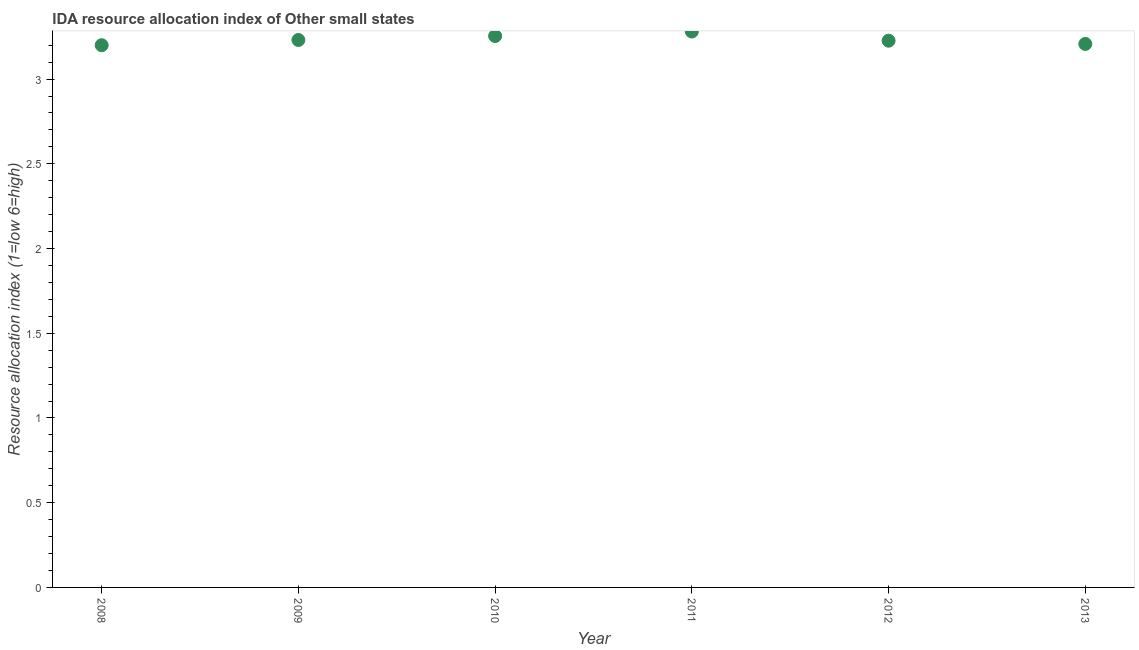Across all years, what is the maximum ida resource allocation index?
Give a very brief answer. 3.28. Across all years, what is the minimum ida resource allocation index?
Your answer should be very brief. 3.2. What is the sum of the ida resource allocation index?
Your response must be concise. 19.4. What is the difference between the ida resource allocation index in 2009 and 2011?
Your answer should be very brief. -0.05. What is the average ida resource allocation index per year?
Ensure brevity in your answer.  3.23. What is the median ida resource allocation index?
Make the answer very short. 3.23. In how many years, is the ida resource allocation index greater than 0.30000000000000004 ?
Your response must be concise. 6. Do a majority of the years between 2009 and 2013 (inclusive) have ida resource allocation index greater than 1.9 ?
Make the answer very short. Yes. What is the ratio of the ida resource allocation index in 2008 to that in 2013?
Offer a very short reply. 1. Is the difference between the ida resource allocation index in 2009 and 2010 greater than the difference between any two years?
Provide a short and direct response. No. What is the difference between the highest and the second highest ida resource allocation index?
Make the answer very short. 0.03. Is the sum of the ida resource allocation index in 2008 and 2010 greater than the maximum ida resource allocation index across all years?
Your answer should be very brief. Yes. What is the difference between the highest and the lowest ida resource allocation index?
Your answer should be compact. 0.08. Does the ida resource allocation index monotonically increase over the years?
Your answer should be compact. No. How many dotlines are there?
Keep it short and to the point. 1. What is the difference between two consecutive major ticks on the Y-axis?
Give a very brief answer. 0.5. Are the values on the major ticks of Y-axis written in scientific E-notation?
Ensure brevity in your answer.  No. Does the graph contain grids?
Give a very brief answer. No. What is the title of the graph?
Ensure brevity in your answer.  IDA resource allocation index of Other small states. What is the label or title of the Y-axis?
Provide a succinct answer. Resource allocation index (1=low 6=high). What is the Resource allocation index (1=low 6=high) in 2008?
Ensure brevity in your answer.  3.2. What is the Resource allocation index (1=low 6=high) in 2009?
Provide a short and direct response. 3.23. What is the Resource allocation index (1=low 6=high) in 2010?
Your answer should be compact. 3.25. What is the Resource allocation index (1=low 6=high) in 2011?
Give a very brief answer. 3.28. What is the Resource allocation index (1=low 6=high) in 2012?
Give a very brief answer. 3.23. What is the Resource allocation index (1=low 6=high) in 2013?
Provide a short and direct response. 3.21. What is the difference between the Resource allocation index (1=low 6=high) in 2008 and 2009?
Your answer should be very brief. -0.03. What is the difference between the Resource allocation index (1=low 6=high) in 2008 and 2010?
Your answer should be very brief. -0.05. What is the difference between the Resource allocation index (1=low 6=high) in 2008 and 2011?
Ensure brevity in your answer.  -0.08. What is the difference between the Resource allocation index (1=low 6=high) in 2008 and 2012?
Your answer should be compact. -0.03. What is the difference between the Resource allocation index (1=low 6=high) in 2008 and 2013?
Make the answer very short. -0.01. What is the difference between the Resource allocation index (1=low 6=high) in 2009 and 2010?
Provide a succinct answer. -0.02. What is the difference between the Resource allocation index (1=low 6=high) in 2009 and 2011?
Provide a succinct answer. -0.05. What is the difference between the Resource allocation index (1=low 6=high) in 2009 and 2012?
Ensure brevity in your answer.  0. What is the difference between the Resource allocation index (1=low 6=high) in 2009 and 2013?
Your answer should be very brief. 0.02. What is the difference between the Resource allocation index (1=low 6=high) in 2010 and 2011?
Your response must be concise. -0.03. What is the difference between the Resource allocation index (1=low 6=high) in 2010 and 2012?
Your response must be concise. 0.03. What is the difference between the Resource allocation index (1=low 6=high) in 2010 and 2013?
Your answer should be compact. 0.05. What is the difference between the Resource allocation index (1=low 6=high) in 2011 and 2012?
Your answer should be very brief. 0.05. What is the difference between the Resource allocation index (1=low 6=high) in 2011 and 2013?
Ensure brevity in your answer.  0.07. What is the difference between the Resource allocation index (1=low 6=high) in 2012 and 2013?
Make the answer very short. 0.02. What is the ratio of the Resource allocation index (1=low 6=high) in 2008 to that in 2010?
Your answer should be compact. 0.98. What is the ratio of the Resource allocation index (1=low 6=high) in 2009 to that in 2010?
Offer a very short reply. 0.99. What is the ratio of the Resource allocation index (1=low 6=high) in 2010 to that in 2011?
Make the answer very short. 0.99. What is the ratio of the Resource allocation index (1=low 6=high) in 2010 to that in 2013?
Your answer should be compact. 1.01. What is the ratio of the Resource allocation index (1=low 6=high) in 2011 to that in 2013?
Your answer should be compact. 1.02. 